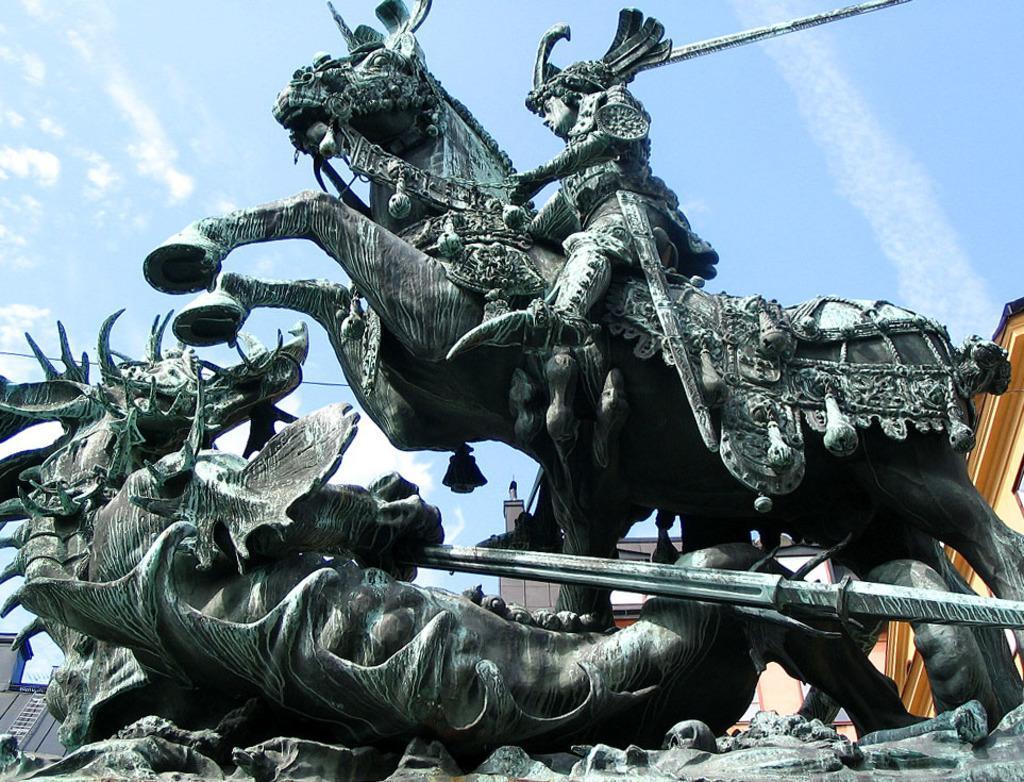How would you summarize this image in a sentence or two? In this image I can see few sculptures in the front. In the background I can see few buildings, clouds and the sky. 